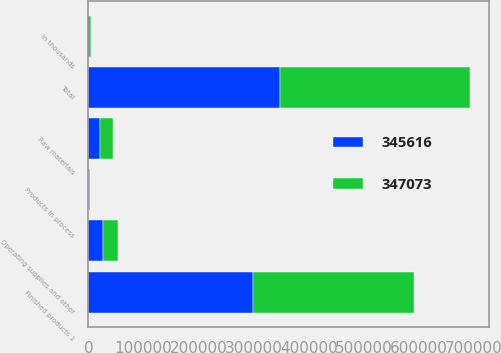<chart> <loc_0><loc_0><loc_500><loc_500><stacked_bar_chart><ecel><fcel>in thousands<fcel>Finished products 1<fcel>Raw materials<fcel>Products in process<fcel>Operating supplies and other<fcel>Total<nl><fcel>347073<fcel>2016<fcel>293619<fcel>22648<fcel>1480<fcel>27869<fcel>345616<nl><fcel>345616<fcel>2015<fcel>297925<fcel>21765<fcel>1008<fcel>26375<fcel>347073<nl></chart> 